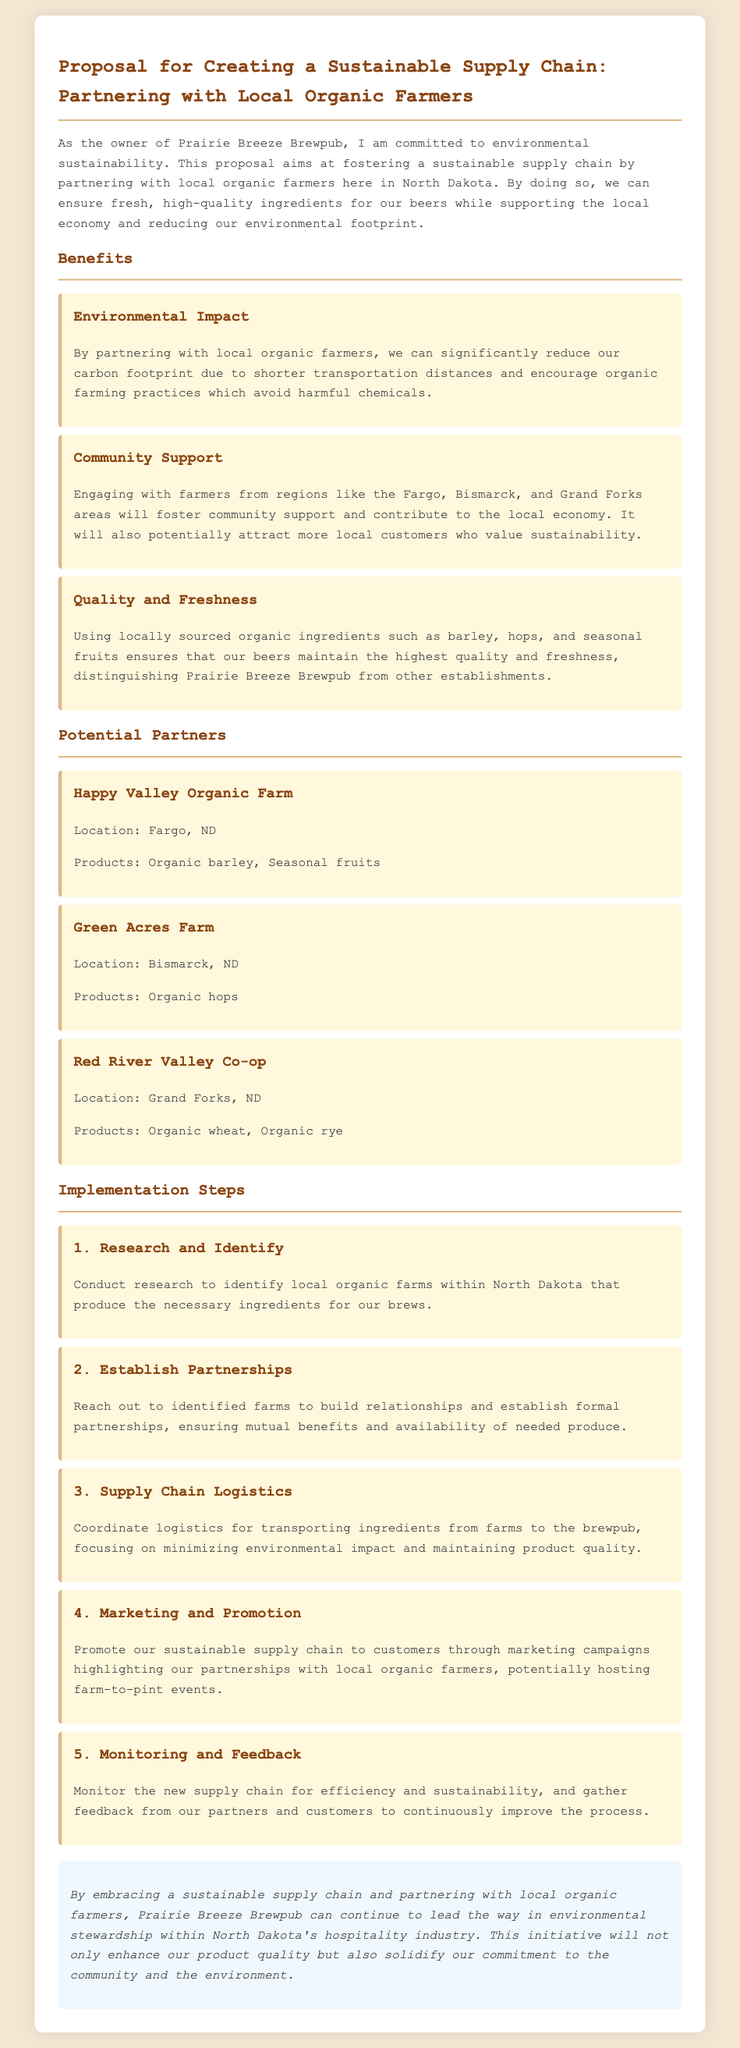What is the title of the proposal? The title states the main focus of the document on creating a sustainable supply chain through partnerships.
Answer: Proposal for Creating a Sustainable Supply Chain: Partnering with Local Organic Farmers What is one benefit of partnering with local organic farmers? The proposal lists benefits in terms of environmental impact, community support, and quality.
Answer: Environmental Impact Which farm is located in Fargo, ND? The document specifies the location of potential partner farms along with their products.
Answer: Happy Valley Organic Farm What are the products of Green Acres Farm? The potential partner farms are associated with the specific products they offer.
Answer: Organic hops What is the first implementation step mentioned? The steps are sequential actions outlined to carry out the proposal effectively.
Answer: Research and Identify How many potential partners are listed in the proposal? The document indicates the number of local organic farms that can be partnered with.
Answer: Three What is one way to promote the sustainable supply chain? The proposal suggests methods for marketing and promoting its initiatives to customers.
Answer: Marketing campaigns What is the main commitment of Prairie Breeze Brewpub? The document concludes with a summary of the overarching goal and commitment of the brewpub.
Answer: Environmental stewardship What type of ingredients will be sourced locally? The focus is on specific ingredients that are obtained from local sources to ensure quality and freshness.
Answer: Organic ingredients 